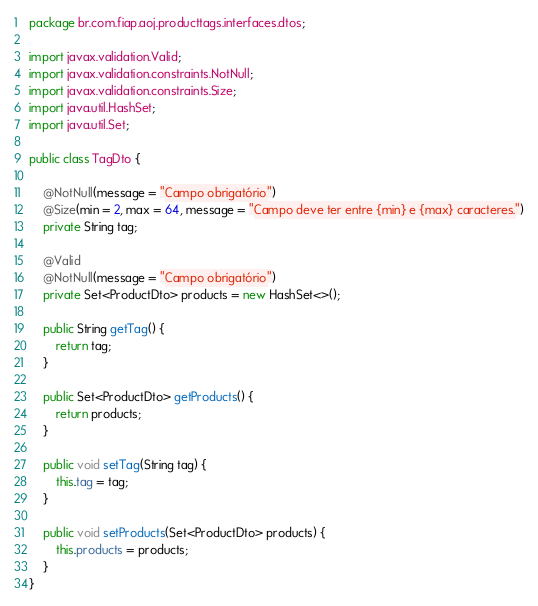<code> <loc_0><loc_0><loc_500><loc_500><_Java_>package br.com.fiap.aoj.producttags.interfaces.dtos;

import javax.validation.Valid;
import javax.validation.constraints.NotNull;
import javax.validation.constraints.Size;
import java.util.HashSet;
import java.util.Set;

public class TagDto {

	@NotNull(message = "Campo obrigatório")
	@Size(min = 2, max = 64, message = "Campo deve ter entre {min} e {max} caracteres.")
	private String tag;

	@Valid
	@NotNull(message = "Campo obrigatório")
	private Set<ProductDto> products = new HashSet<>();

	public String getTag() {
		return tag;
	}

	public Set<ProductDto> getProducts() {
		return products;
	}

	public void setTag(String tag) {
		this.tag = tag;
	}

	public void setProducts(Set<ProductDto> products) {
		this.products = products;
	}
}
</code> 